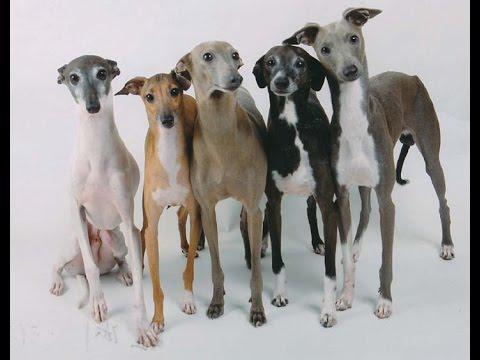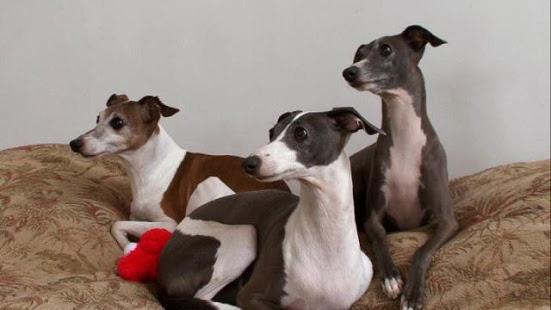The first image is the image on the left, the second image is the image on the right. Assess this claim about the two images: "there are only two canines in the image on the right side". Correct or not? Answer yes or no. No. The first image is the image on the left, the second image is the image on the right. Considering the images on both sides, is "One image contains five dogs." valid? Answer yes or no. Yes. 